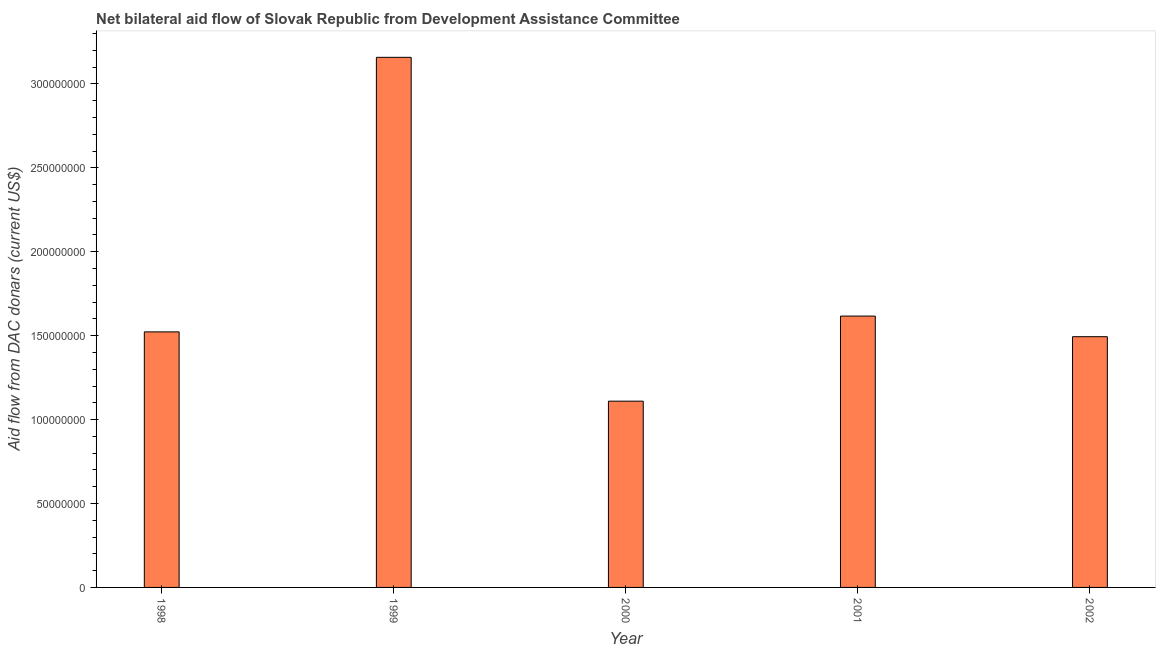What is the title of the graph?
Make the answer very short. Net bilateral aid flow of Slovak Republic from Development Assistance Committee. What is the label or title of the Y-axis?
Provide a succinct answer. Aid flow from DAC donars (current US$). What is the net bilateral aid flows from dac donors in 2000?
Your response must be concise. 1.11e+08. Across all years, what is the maximum net bilateral aid flows from dac donors?
Your answer should be very brief. 3.16e+08. Across all years, what is the minimum net bilateral aid flows from dac donors?
Your response must be concise. 1.11e+08. In which year was the net bilateral aid flows from dac donors maximum?
Offer a terse response. 1999. What is the sum of the net bilateral aid flows from dac donors?
Your answer should be very brief. 8.90e+08. What is the difference between the net bilateral aid flows from dac donors in 1998 and 2001?
Your answer should be compact. -9.41e+06. What is the average net bilateral aid flows from dac donors per year?
Offer a very short reply. 1.78e+08. What is the median net bilateral aid flows from dac donors?
Keep it short and to the point. 1.52e+08. In how many years, is the net bilateral aid flows from dac donors greater than 140000000 US$?
Your answer should be very brief. 4. What is the ratio of the net bilateral aid flows from dac donors in 1998 to that in 2000?
Your answer should be very brief. 1.37. Is the difference between the net bilateral aid flows from dac donors in 1998 and 2001 greater than the difference between any two years?
Offer a very short reply. No. What is the difference between the highest and the second highest net bilateral aid flows from dac donors?
Give a very brief answer. 1.54e+08. What is the difference between the highest and the lowest net bilateral aid flows from dac donors?
Give a very brief answer. 2.05e+08. In how many years, is the net bilateral aid flows from dac donors greater than the average net bilateral aid flows from dac donors taken over all years?
Your response must be concise. 1. How many years are there in the graph?
Give a very brief answer. 5. What is the difference between two consecutive major ticks on the Y-axis?
Offer a terse response. 5.00e+07. Are the values on the major ticks of Y-axis written in scientific E-notation?
Offer a very short reply. No. What is the Aid flow from DAC donars (current US$) in 1998?
Provide a succinct answer. 1.52e+08. What is the Aid flow from DAC donars (current US$) in 1999?
Ensure brevity in your answer.  3.16e+08. What is the Aid flow from DAC donars (current US$) of 2000?
Provide a succinct answer. 1.11e+08. What is the Aid flow from DAC donars (current US$) in 2001?
Give a very brief answer. 1.62e+08. What is the Aid flow from DAC donars (current US$) in 2002?
Your answer should be compact. 1.49e+08. What is the difference between the Aid flow from DAC donars (current US$) in 1998 and 1999?
Offer a very short reply. -1.64e+08. What is the difference between the Aid flow from DAC donars (current US$) in 1998 and 2000?
Keep it short and to the point. 4.13e+07. What is the difference between the Aid flow from DAC donars (current US$) in 1998 and 2001?
Make the answer very short. -9.41e+06. What is the difference between the Aid flow from DAC donars (current US$) in 1998 and 2002?
Keep it short and to the point. 2.87e+06. What is the difference between the Aid flow from DAC donars (current US$) in 1999 and 2000?
Your answer should be compact. 2.05e+08. What is the difference between the Aid flow from DAC donars (current US$) in 1999 and 2001?
Give a very brief answer. 1.54e+08. What is the difference between the Aid flow from DAC donars (current US$) in 1999 and 2002?
Offer a very short reply. 1.66e+08. What is the difference between the Aid flow from DAC donars (current US$) in 2000 and 2001?
Provide a succinct answer. -5.07e+07. What is the difference between the Aid flow from DAC donars (current US$) in 2000 and 2002?
Your answer should be very brief. -3.84e+07. What is the difference between the Aid flow from DAC donars (current US$) in 2001 and 2002?
Ensure brevity in your answer.  1.23e+07. What is the ratio of the Aid flow from DAC donars (current US$) in 1998 to that in 1999?
Offer a terse response. 0.48. What is the ratio of the Aid flow from DAC donars (current US$) in 1998 to that in 2000?
Provide a succinct answer. 1.37. What is the ratio of the Aid flow from DAC donars (current US$) in 1998 to that in 2001?
Your response must be concise. 0.94. What is the ratio of the Aid flow from DAC donars (current US$) in 1998 to that in 2002?
Provide a short and direct response. 1.02. What is the ratio of the Aid flow from DAC donars (current US$) in 1999 to that in 2000?
Give a very brief answer. 2.85. What is the ratio of the Aid flow from DAC donars (current US$) in 1999 to that in 2001?
Offer a terse response. 1.95. What is the ratio of the Aid flow from DAC donars (current US$) in 1999 to that in 2002?
Your answer should be compact. 2.11. What is the ratio of the Aid flow from DAC donars (current US$) in 2000 to that in 2001?
Keep it short and to the point. 0.69. What is the ratio of the Aid flow from DAC donars (current US$) in 2000 to that in 2002?
Make the answer very short. 0.74. What is the ratio of the Aid flow from DAC donars (current US$) in 2001 to that in 2002?
Keep it short and to the point. 1.08. 